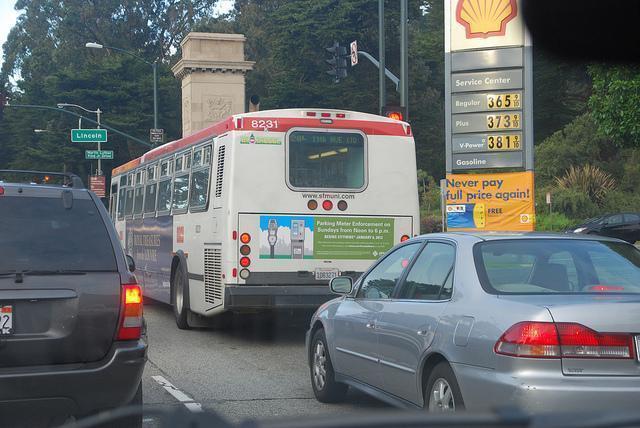What does the business sell?
Select the correct answer and articulate reasoning with the following format: 'Answer: answer
Rationale: rationale.'
Options: Animals, books, gas, electronics. Answer: gas.
Rationale: The sign is for a shell station where fuel can be purchased to power vehicles. 